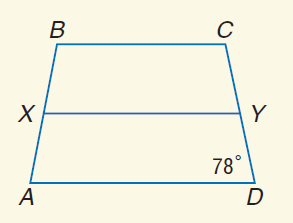Answer the mathemtical geometry problem and directly provide the correct option letter.
Question: For isosceles trapezoid A B C D, X and Y are midpoints of the legs. Find m \angle X B C if m \angle A D Y = 78.
Choices: A: 39 B: 51 C: 78 D: 102 D 